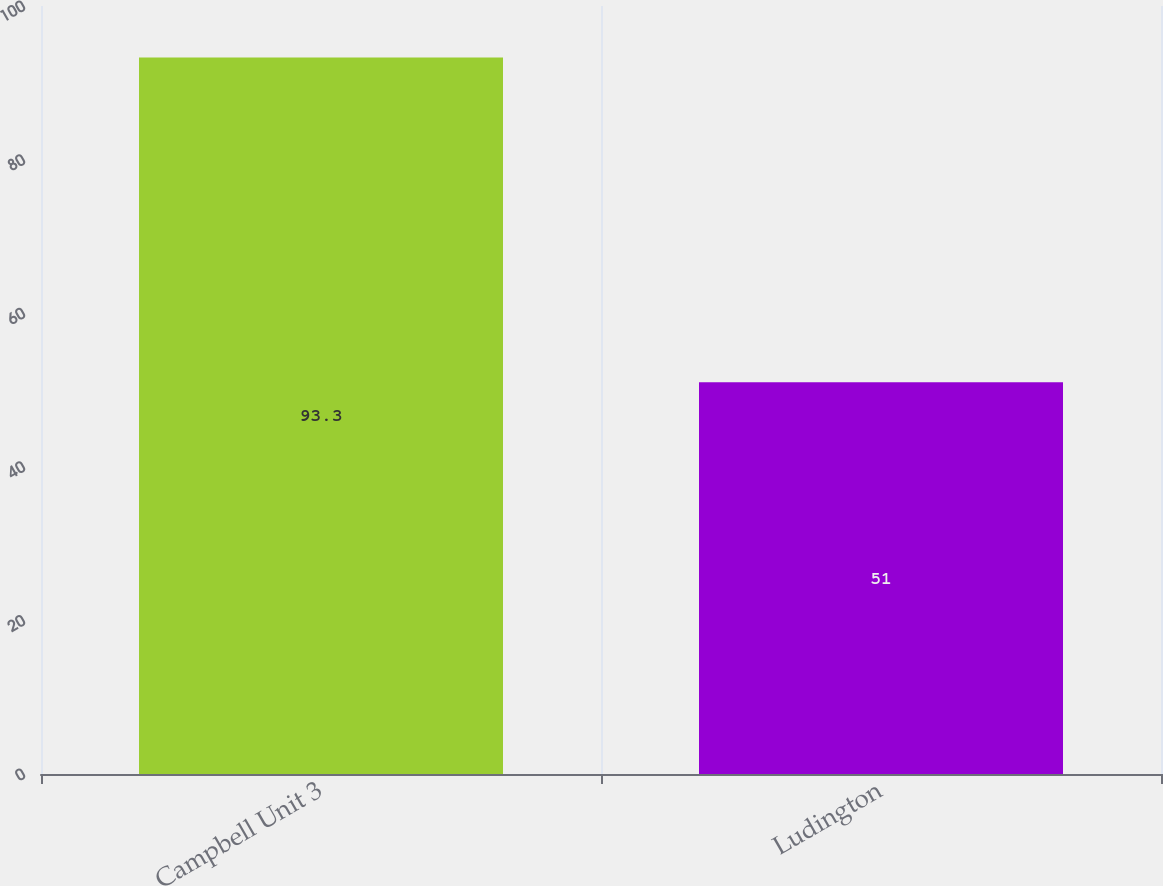<chart> <loc_0><loc_0><loc_500><loc_500><bar_chart><fcel>Campbell Unit 3<fcel>Ludington<nl><fcel>93.3<fcel>51<nl></chart> 